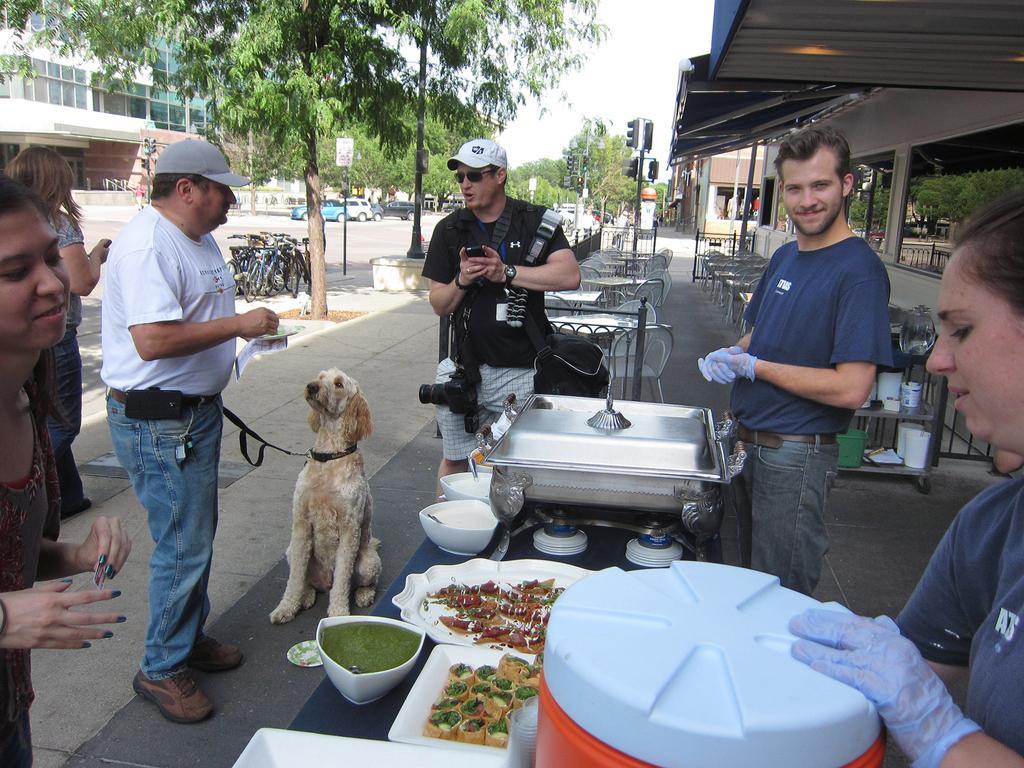How would you summarize this image in a sentence or two? There are three members standing in front of a table. On the other side two of them are cooking some food on the table. One middle guy is feeding the dog which is sitting in front of him. In the background there are some trees, buildings, bicycles and cars. We can observe some traffic signals and sky. 